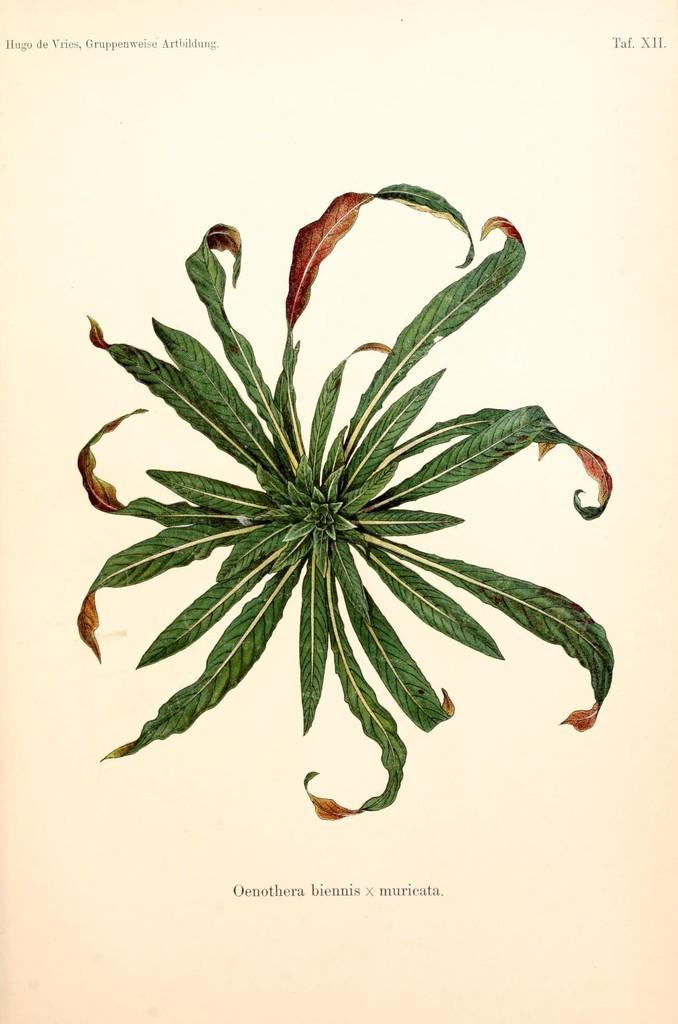Can you describe this image briefly? In this image I can see leaves and text and this image looks like paper cutting of books. 